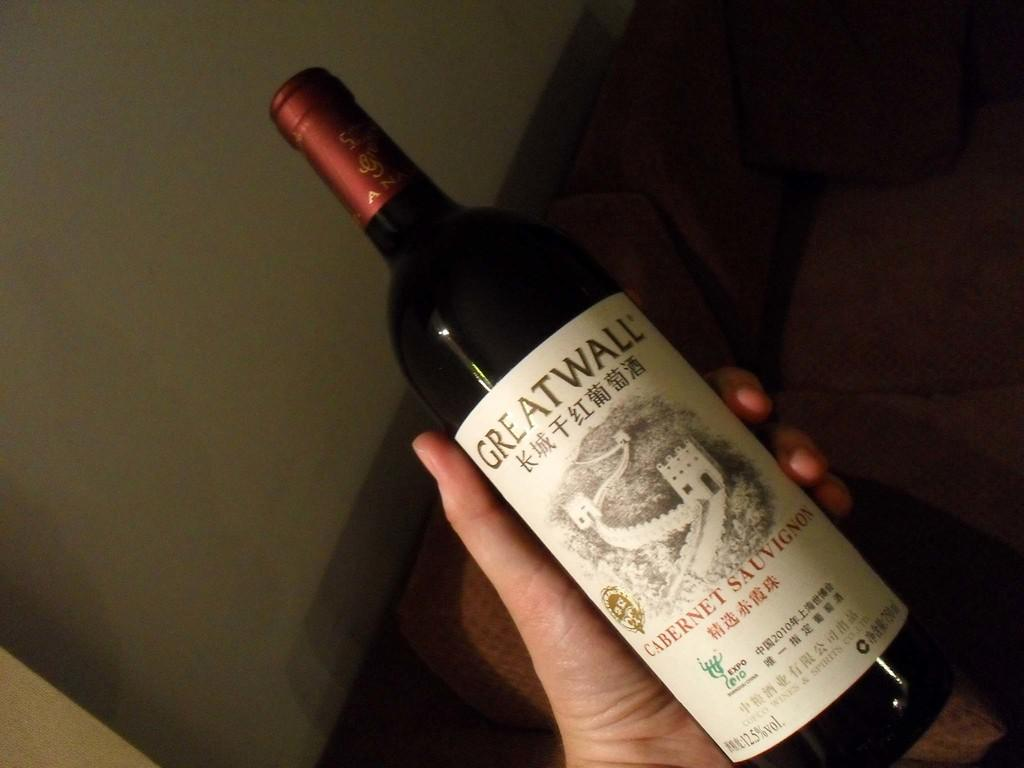<image>
Create a compact narrative representing the image presented. The bottle of wine says GREATWALL and is full. 